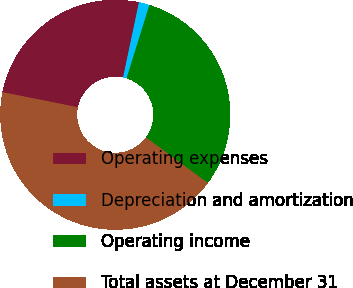Convert chart. <chart><loc_0><loc_0><loc_500><loc_500><pie_chart><fcel>Operating expenses<fcel>Depreciation and amortization<fcel>Operating income<fcel>Total assets at December 31<nl><fcel>25.18%<fcel>1.49%<fcel>30.31%<fcel>43.03%<nl></chart> 